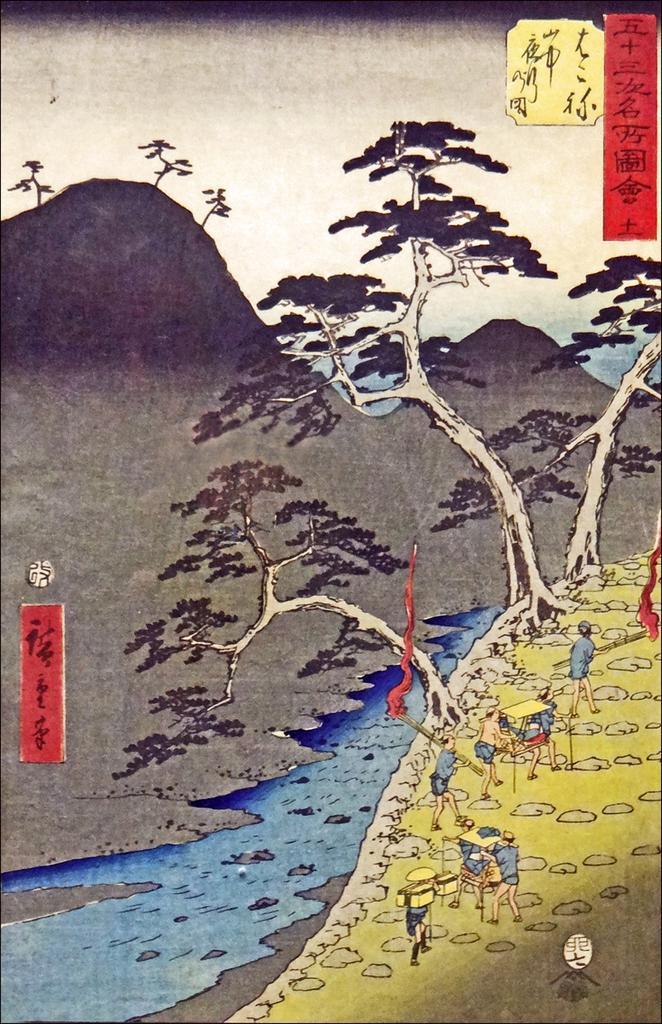Could you give a brief overview of what you see in this image? In this image, we can see some poster. Here we can see a group of people, some objects. In the middle, we can see a water. Top of the image, we can see mountains, trees. Right side and left side of the image, we can see some text. 